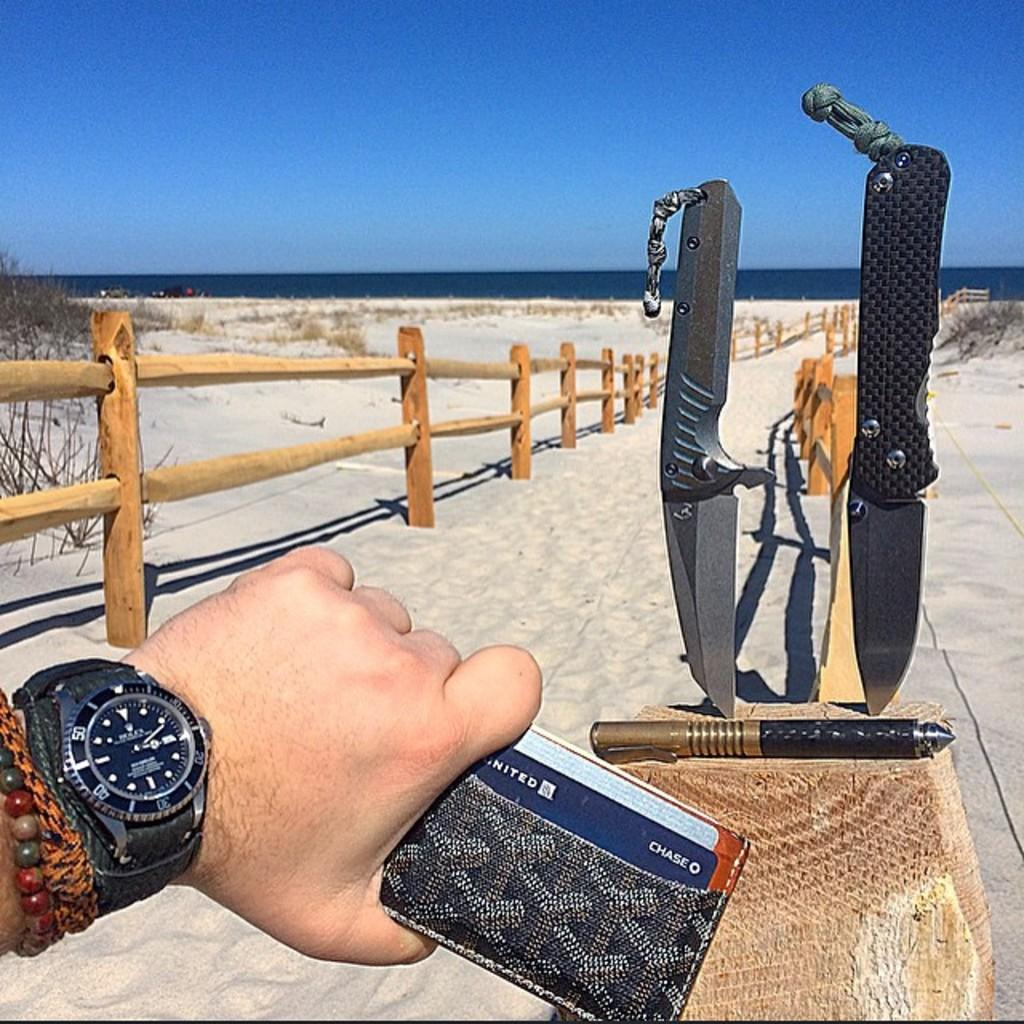What is the human hand holding in the image? There is a human hand holding an object in the image, but the specific object cannot be determined from the facts provided. What type of sharp utensils can be seen in the image? There are knives visible in the image. What type of architectural feature is present in the image? There is a wooden railing in the image. What type of living organisms are visible in the image? There are plants in the image. What part of the natural environment is visible in the image? The sky is visible in the image. What type of sofa is visible in the image? There is no sofa present in the image. What type of ornament is hanging from the wooden railing in the image? There is no ornament hanging from the wooden railing in the image. 